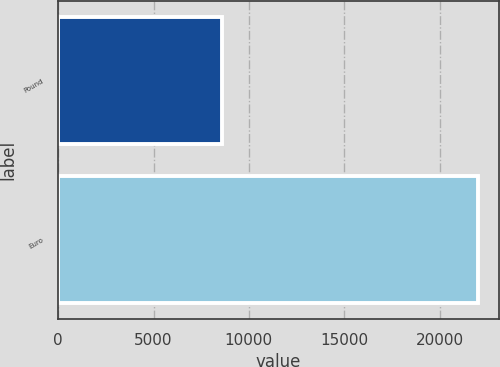Convert chart to OTSL. <chart><loc_0><loc_0><loc_500><loc_500><bar_chart><fcel>Pound<fcel>Euro<nl><fcel>8569<fcel>22000<nl></chart> 